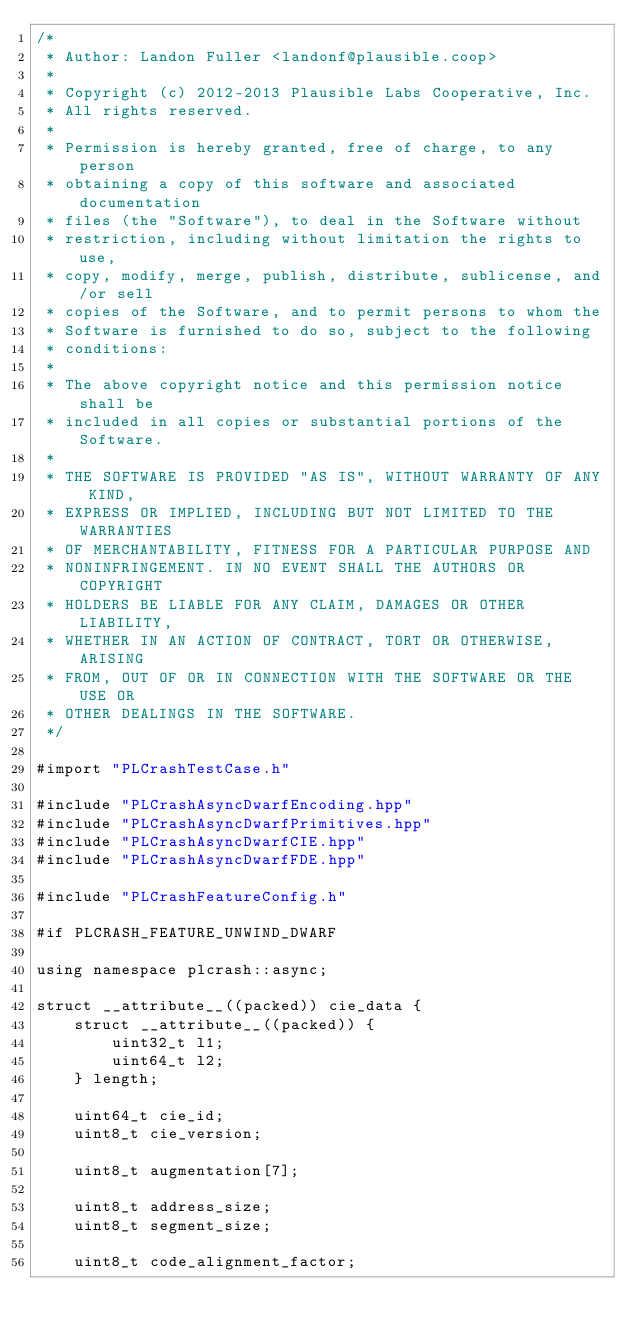Convert code to text. <code><loc_0><loc_0><loc_500><loc_500><_ObjectiveC_>/*
 * Author: Landon Fuller <landonf@plausible.coop>
 *
 * Copyright (c) 2012-2013 Plausible Labs Cooperative, Inc.
 * All rights reserved.
 *
 * Permission is hereby granted, free of charge, to any person
 * obtaining a copy of this software and associated documentation
 * files (the "Software"), to deal in the Software without
 * restriction, including without limitation the rights to use,
 * copy, modify, merge, publish, distribute, sublicense, and/or sell
 * copies of the Software, and to permit persons to whom the
 * Software is furnished to do so, subject to the following
 * conditions:
 *
 * The above copyright notice and this permission notice shall be
 * included in all copies or substantial portions of the Software.
 *
 * THE SOFTWARE IS PROVIDED "AS IS", WITHOUT WARRANTY OF ANY KIND,
 * EXPRESS OR IMPLIED, INCLUDING BUT NOT LIMITED TO THE WARRANTIES
 * OF MERCHANTABILITY, FITNESS FOR A PARTICULAR PURPOSE AND
 * NONINFRINGEMENT. IN NO EVENT SHALL THE AUTHORS OR COPYRIGHT
 * HOLDERS BE LIABLE FOR ANY CLAIM, DAMAGES OR OTHER LIABILITY,
 * WHETHER IN AN ACTION OF CONTRACT, TORT OR OTHERWISE, ARISING
 * FROM, OUT OF OR IN CONNECTION WITH THE SOFTWARE OR THE USE OR
 * OTHER DEALINGS IN THE SOFTWARE.
 */

#import "PLCrashTestCase.h"

#include "PLCrashAsyncDwarfEncoding.hpp"
#include "PLCrashAsyncDwarfPrimitives.hpp"
#include "PLCrashAsyncDwarfCIE.hpp"
#include "PLCrashAsyncDwarfFDE.hpp"

#include "PLCrashFeatureConfig.h"

#if PLCRASH_FEATURE_UNWIND_DWARF

using namespace plcrash::async;

struct __attribute__((packed)) cie_data {
    struct __attribute__((packed)) {
        uint32_t l1;
        uint64_t l2;
    } length;
    
    uint64_t cie_id;
    uint8_t cie_version;
    
    uint8_t augmentation[7];
    
    uint8_t address_size;
    uint8_t segment_size;
    
    uint8_t code_alignment_factor;</code> 